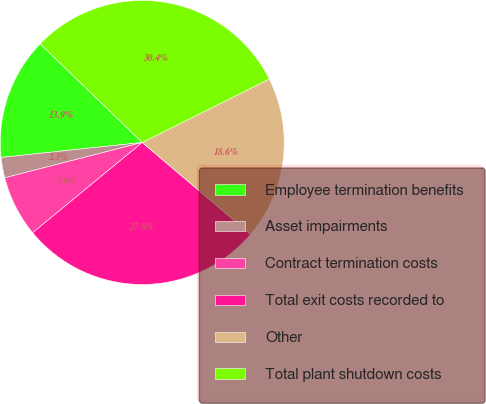<chart> <loc_0><loc_0><loc_500><loc_500><pie_chart><fcel>Employee termination benefits<fcel>Asset impairments<fcel>Contract termination costs<fcel>Total exit costs recorded to<fcel>Other<fcel>Total plant shutdown costs<nl><fcel>13.92%<fcel>2.32%<fcel>6.96%<fcel>27.84%<fcel>18.56%<fcel>30.39%<nl></chart> 